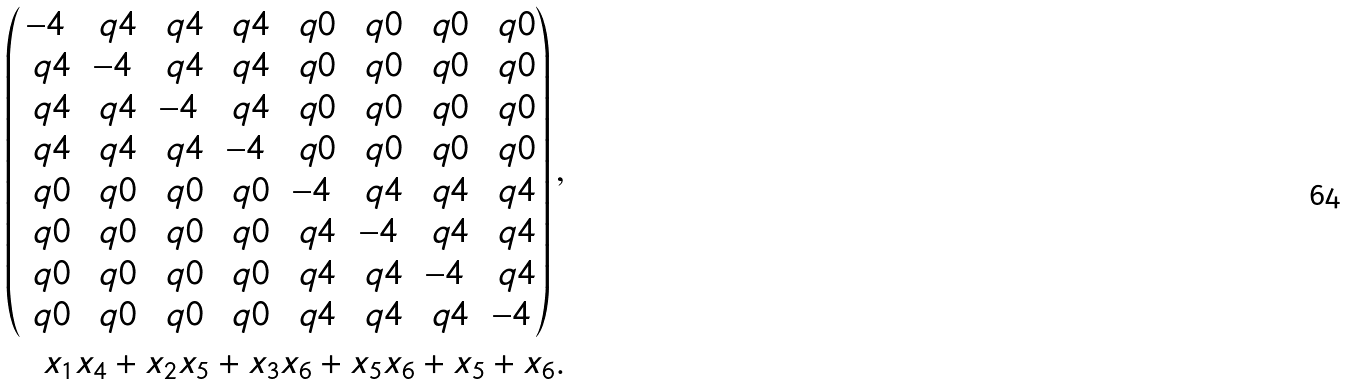Convert formula to latex. <formula><loc_0><loc_0><loc_500><loc_500>\left ( \begin{matrix} - 4 & \ q 4 & \ q 4 & \ q 4 & \ q 0 & \ q 0 & \ q 0 & \ q 0 \\ \ q 4 & - 4 & \ q 4 & \ q 4 & \ q 0 & \ q 0 & \ q 0 & \ q 0 \\ \ q 4 & \ q 4 & - 4 & \ q 4 & \ q 0 & \ q 0 & \ q 0 & \ q 0 \\ \ q 4 & \ q 4 & \ q 4 & - 4 & \ q 0 & \ q 0 & \ q 0 & \ q 0 \\ \ q 0 & \ q 0 & \ q 0 & \ q 0 & - 4 & \ q 4 & \ q 4 & \ q 4 \\ \ q 0 & \ q 0 & \ q 0 & \ q 0 & \ q 4 & - 4 & \ q 4 & \ q 4 \\ \ q 0 & \ q 0 & \ q 0 & \ q 0 & \ q 4 & \ q 4 & - 4 & \ q 4 \\ \ q 0 & \ q 0 & \ q 0 & \ q 0 & \ q 4 & \ q 4 & \ q 4 & - 4 \\ \end{matrix} \right ) , \\ x _ { 1 } x _ { 4 } + x _ { 2 } x _ { 5 } + x _ { 3 } x _ { 6 } + x _ { 5 } x _ { 6 } + x _ { 5 } + x _ { 6 } .</formula> 